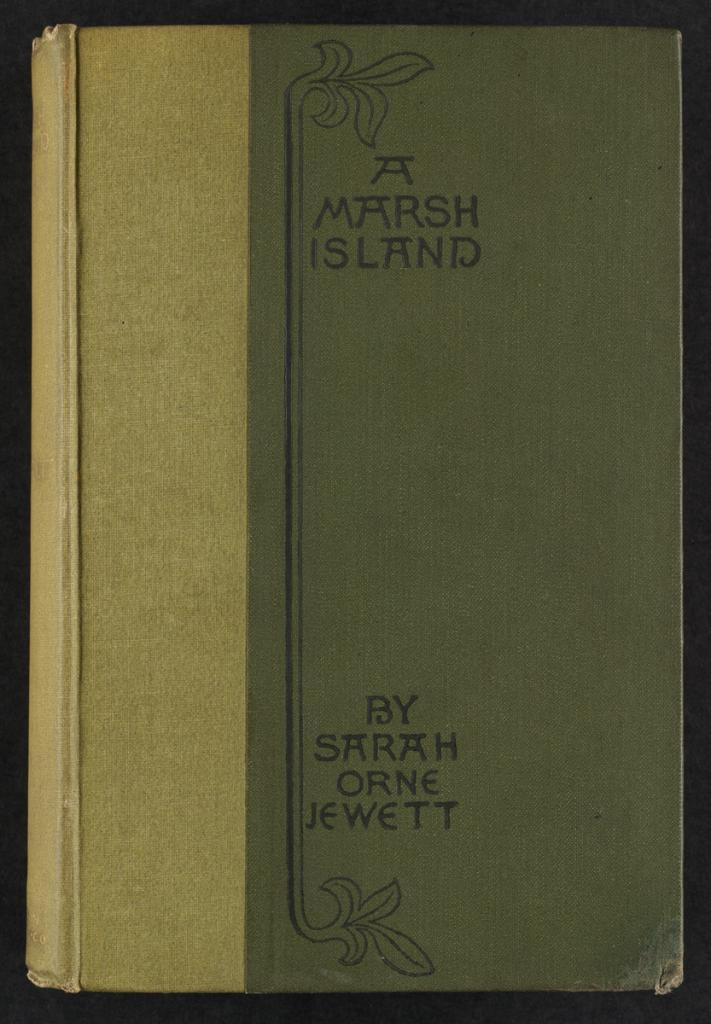<image>
Create a compact narrative representing the image presented. An old book by Sarah Orne Jewett has a two tone green cover. 